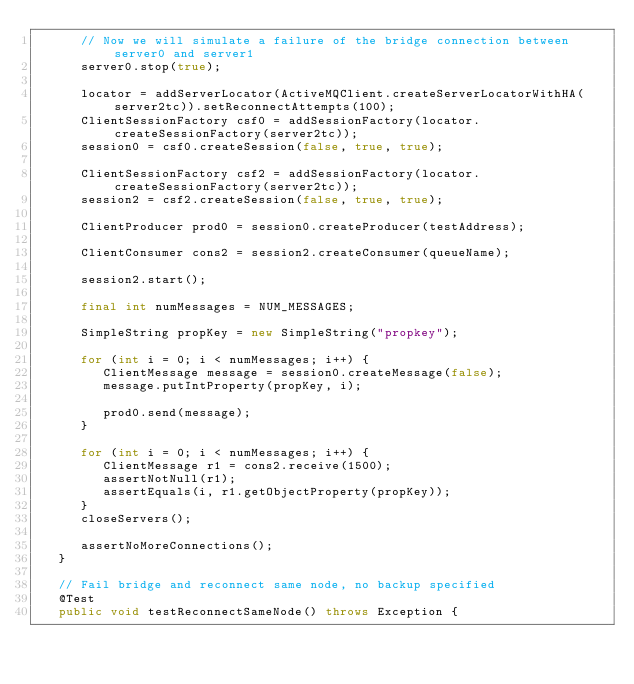<code> <loc_0><loc_0><loc_500><loc_500><_Java_>      // Now we will simulate a failure of the bridge connection between server0 and server1
      server0.stop(true);

      locator = addServerLocator(ActiveMQClient.createServerLocatorWithHA(server2tc)).setReconnectAttempts(100);
      ClientSessionFactory csf0 = addSessionFactory(locator.createSessionFactory(server2tc));
      session0 = csf0.createSession(false, true, true);

      ClientSessionFactory csf2 = addSessionFactory(locator.createSessionFactory(server2tc));
      session2 = csf2.createSession(false, true, true);

      ClientProducer prod0 = session0.createProducer(testAddress);

      ClientConsumer cons2 = session2.createConsumer(queueName);

      session2.start();

      final int numMessages = NUM_MESSAGES;

      SimpleString propKey = new SimpleString("propkey");

      for (int i = 0; i < numMessages; i++) {
         ClientMessage message = session0.createMessage(false);
         message.putIntProperty(propKey, i);

         prod0.send(message);
      }

      for (int i = 0; i < numMessages; i++) {
         ClientMessage r1 = cons2.receive(1500);
         assertNotNull(r1);
         assertEquals(i, r1.getObjectProperty(propKey));
      }
      closeServers();

      assertNoMoreConnections();
   }

   // Fail bridge and reconnect same node, no backup specified
   @Test
   public void testReconnectSameNode() throws Exception {</code> 